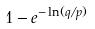<formula> <loc_0><loc_0><loc_500><loc_500>1 - e ^ { - \ln ( q / p ) }</formula> 